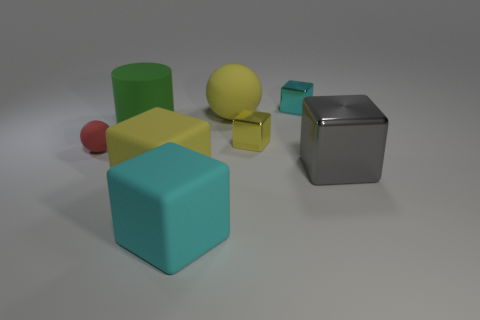Is the size of the green cylinder the same as the gray thing?
Offer a terse response. Yes. How many small metal objects are both right of the tiny yellow shiny thing and in front of the tiny cyan shiny block?
Ensure brevity in your answer.  0. How many purple things are either rubber things or spheres?
Keep it short and to the point. 0. How many metallic things are either gray cubes or big green cylinders?
Provide a succinct answer. 1. Is there a small yellow rubber object?
Offer a terse response. No. Is the small yellow shiny thing the same shape as the small cyan metallic thing?
Keep it short and to the point. Yes. How many big yellow balls are left of the yellow matte thing right of the yellow object in front of the small matte thing?
Offer a very short reply. 0. There is a tiny object that is both in front of the cylinder and to the right of the green object; what material is it made of?
Offer a very short reply. Metal. There is a big object that is on the right side of the cyan matte block and to the left of the tiny yellow cube; what is its color?
Your answer should be compact. Yellow. Are there any other things of the same color as the big ball?
Keep it short and to the point. Yes. 